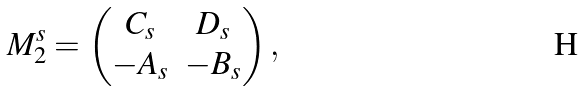<formula> <loc_0><loc_0><loc_500><loc_500>M _ { 2 } ^ { s } = \begin{pmatrix} C _ { s } & D _ { s } \\ - A _ { s } & - B _ { s } \end{pmatrix} ,</formula> 